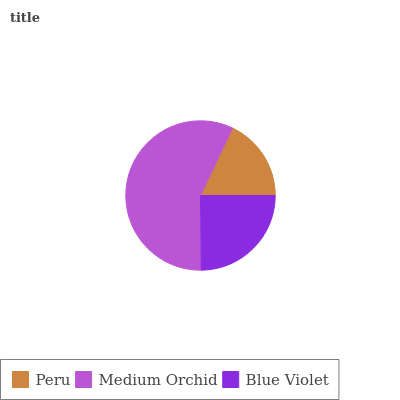Is Peru the minimum?
Answer yes or no. Yes. Is Medium Orchid the maximum?
Answer yes or no. Yes. Is Blue Violet the minimum?
Answer yes or no. No. Is Blue Violet the maximum?
Answer yes or no. No. Is Medium Orchid greater than Blue Violet?
Answer yes or no. Yes. Is Blue Violet less than Medium Orchid?
Answer yes or no. Yes. Is Blue Violet greater than Medium Orchid?
Answer yes or no. No. Is Medium Orchid less than Blue Violet?
Answer yes or no. No. Is Blue Violet the high median?
Answer yes or no. Yes. Is Blue Violet the low median?
Answer yes or no. Yes. Is Medium Orchid the high median?
Answer yes or no. No. Is Peru the low median?
Answer yes or no. No. 